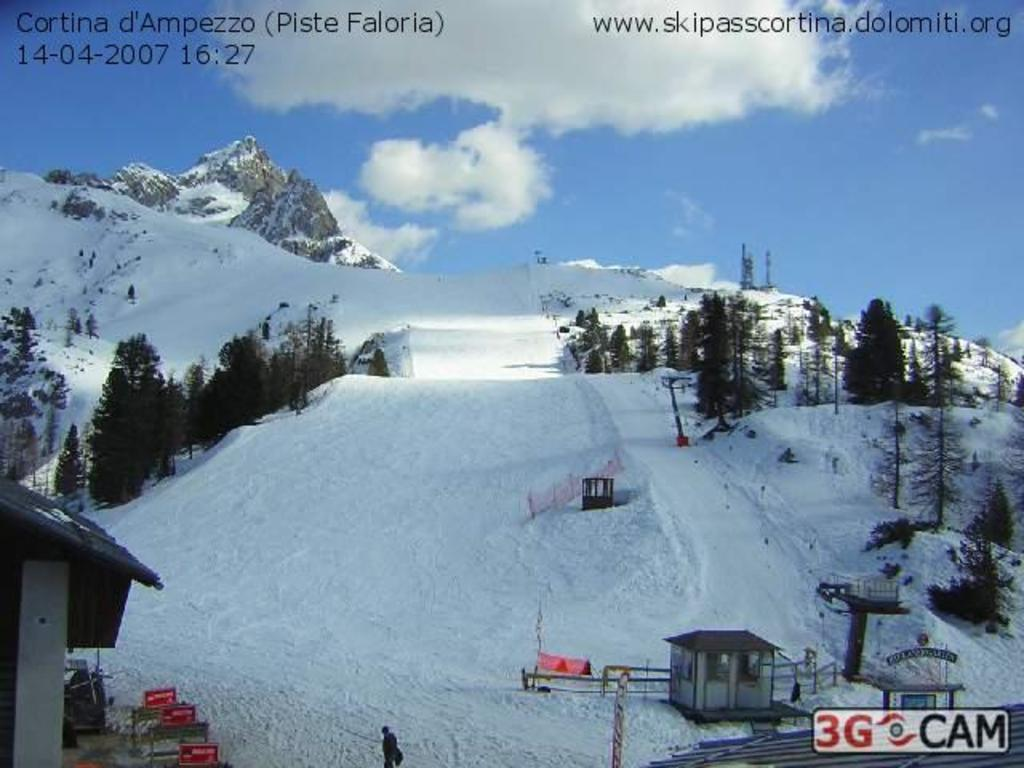What type of weather is depicted in the image? There is snow in the image, indicating a winter scene. What natural elements can be seen in the image? There are trees, mountains, and a house in the image. Who or what is present in the image? There is a person in the image. What is visible in the sky? The sky is visible in the image, and there are clouds present. What color is the crayon being used by the person in the image? There is no crayon present in the image; it is a winter scene with snow, trees, mountains, a house, and a person. 